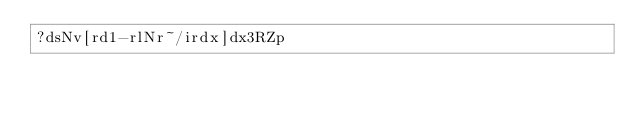Convert code to text. <code><loc_0><loc_0><loc_500><loc_500><_dc_>?dsNv[rd1-rlNr~/irdx]dx3RZp</code> 